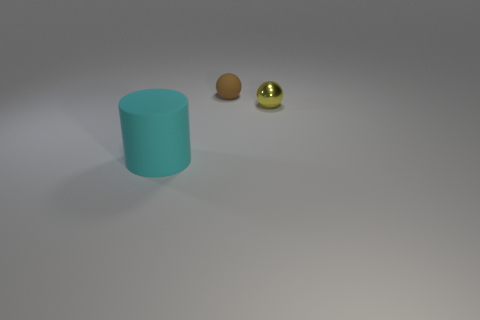Add 3 big gray shiny blocks. How many objects exist? 6 Subtract all cylinders. How many objects are left? 2 Add 2 small brown rubber spheres. How many small brown rubber spheres are left? 3 Add 3 yellow metallic objects. How many yellow metallic objects exist? 4 Subtract 0 green cylinders. How many objects are left? 3 Subtract all balls. Subtract all matte cylinders. How many objects are left? 0 